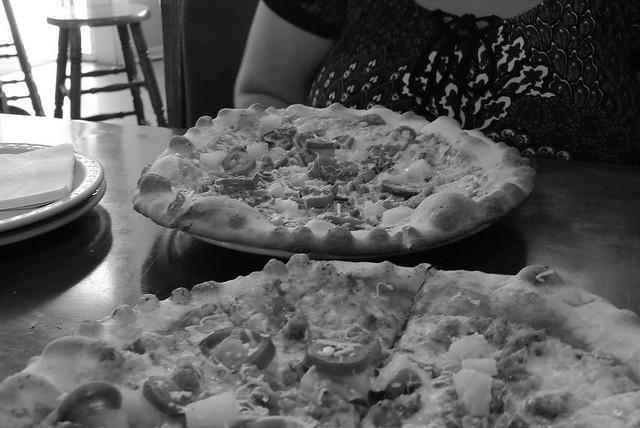Where was this food placed during cooking?

Choices:
A) counter top
B) deep fryer
C) microwave
D) oven oven 